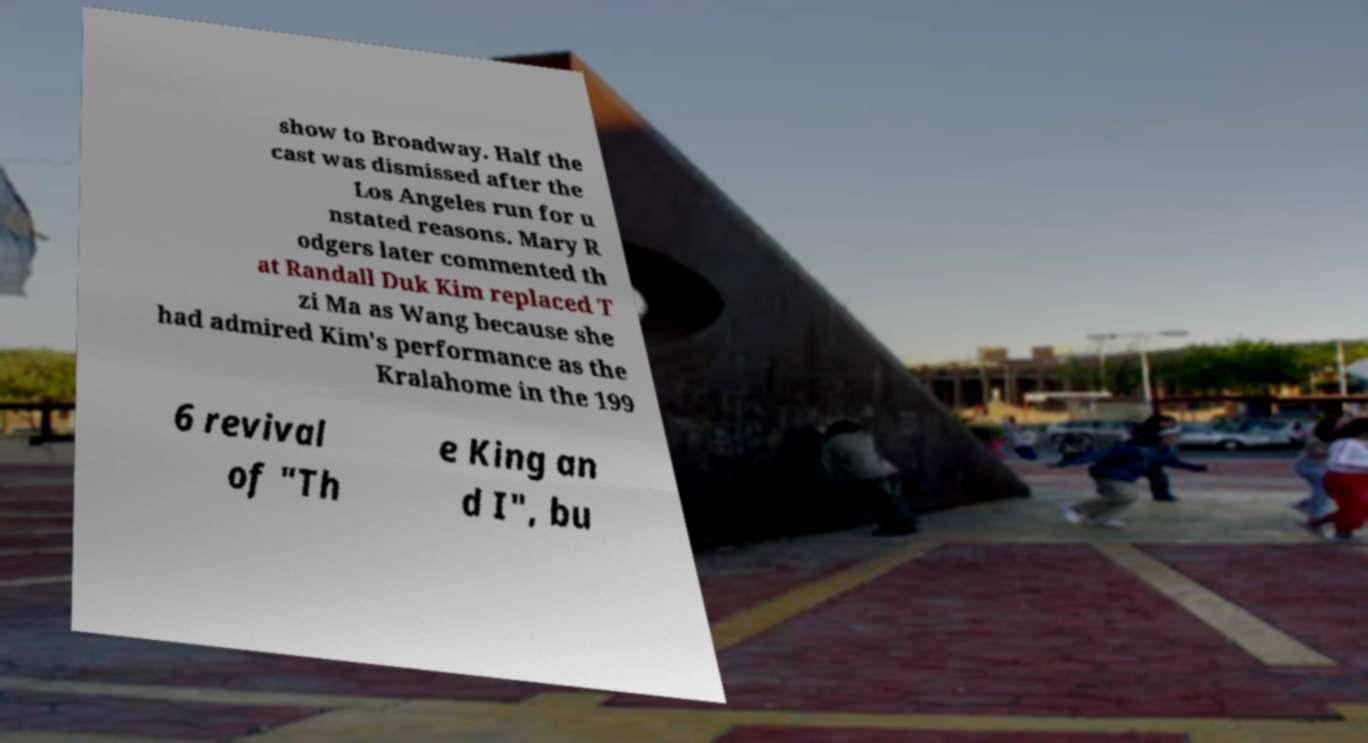For documentation purposes, I need the text within this image transcribed. Could you provide that? show to Broadway. Half the cast was dismissed after the Los Angeles run for u nstated reasons. Mary R odgers later commented th at Randall Duk Kim replaced T zi Ma as Wang because she had admired Kim's performance as the Kralahome in the 199 6 revival of "Th e King an d I", bu 